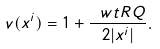<formula> <loc_0><loc_0><loc_500><loc_500>v ( x ^ { i } ) = 1 + \frac { \ w t R Q } { 2 | x ^ { i } | } .</formula> 